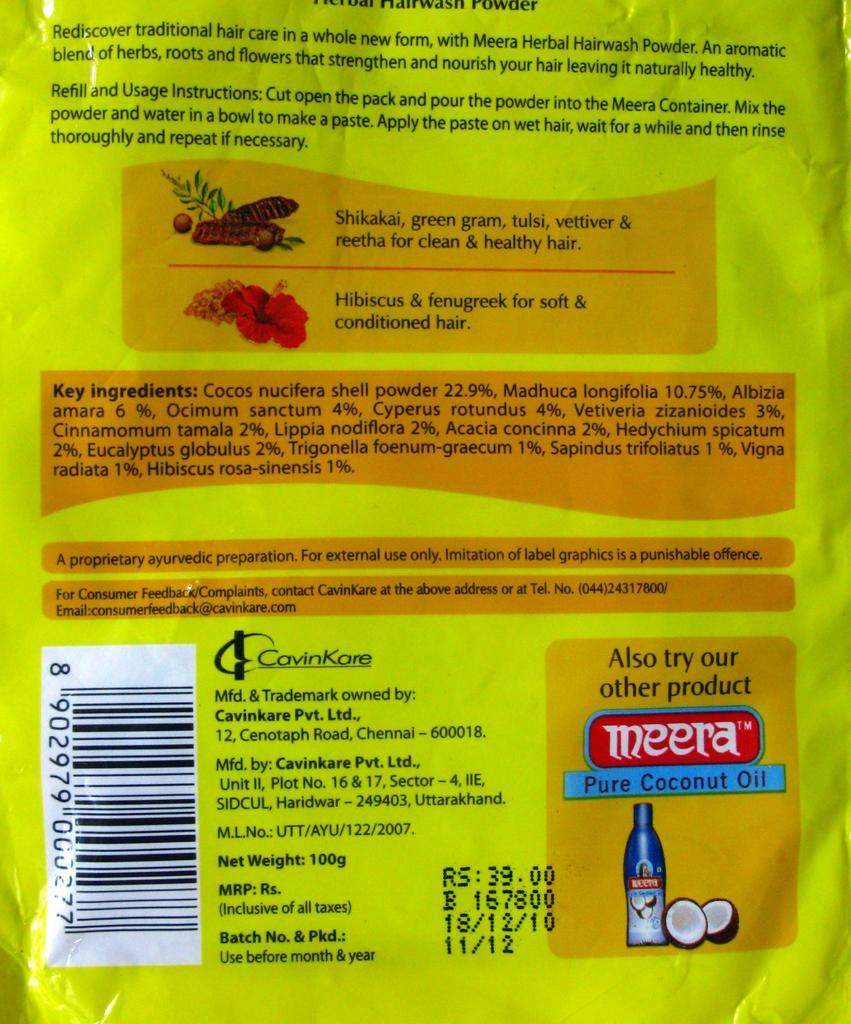What is the main object in the image? There is a shampoo sachet in the image. What can be seen on the shampoo sachet? There is a bar code on the shampoo sachet. What information might be found on the shampoo sachet? There is something written on the shampoo sachet. Can you tell me how many friends are present in the image? There are no friends present in the image; it features a shampoo sachet. What type of medical facility is visible in the image? There is no medical facility present in the image; it features a shampoo sachet. 